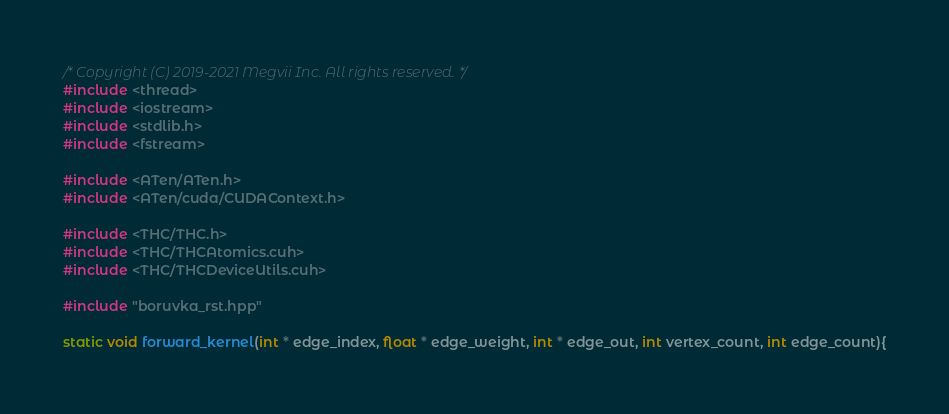Convert code to text. <code><loc_0><loc_0><loc_500><loc_500><_Cuda_>/* Copyright (C) 2019-2021 Megvii Inc. All rights reserved. */
#include <thread>
#include <iostream>
#include <stdlib.h>
#include <fstream>

#include <ATen/ATen.h>
#include <ATen/cuda/CUDAContext.h>

#include <THC/THC.h>
#include <THC/THCAtomics.cuh>
#include <THC/THCDeviceUtils.cuh>

#include "boruvka_rst.hpp"

static void forward_kernel(int * edge_index, float * edge_weight, int * edge_out, int vertex_count, int edge_count){</code> 